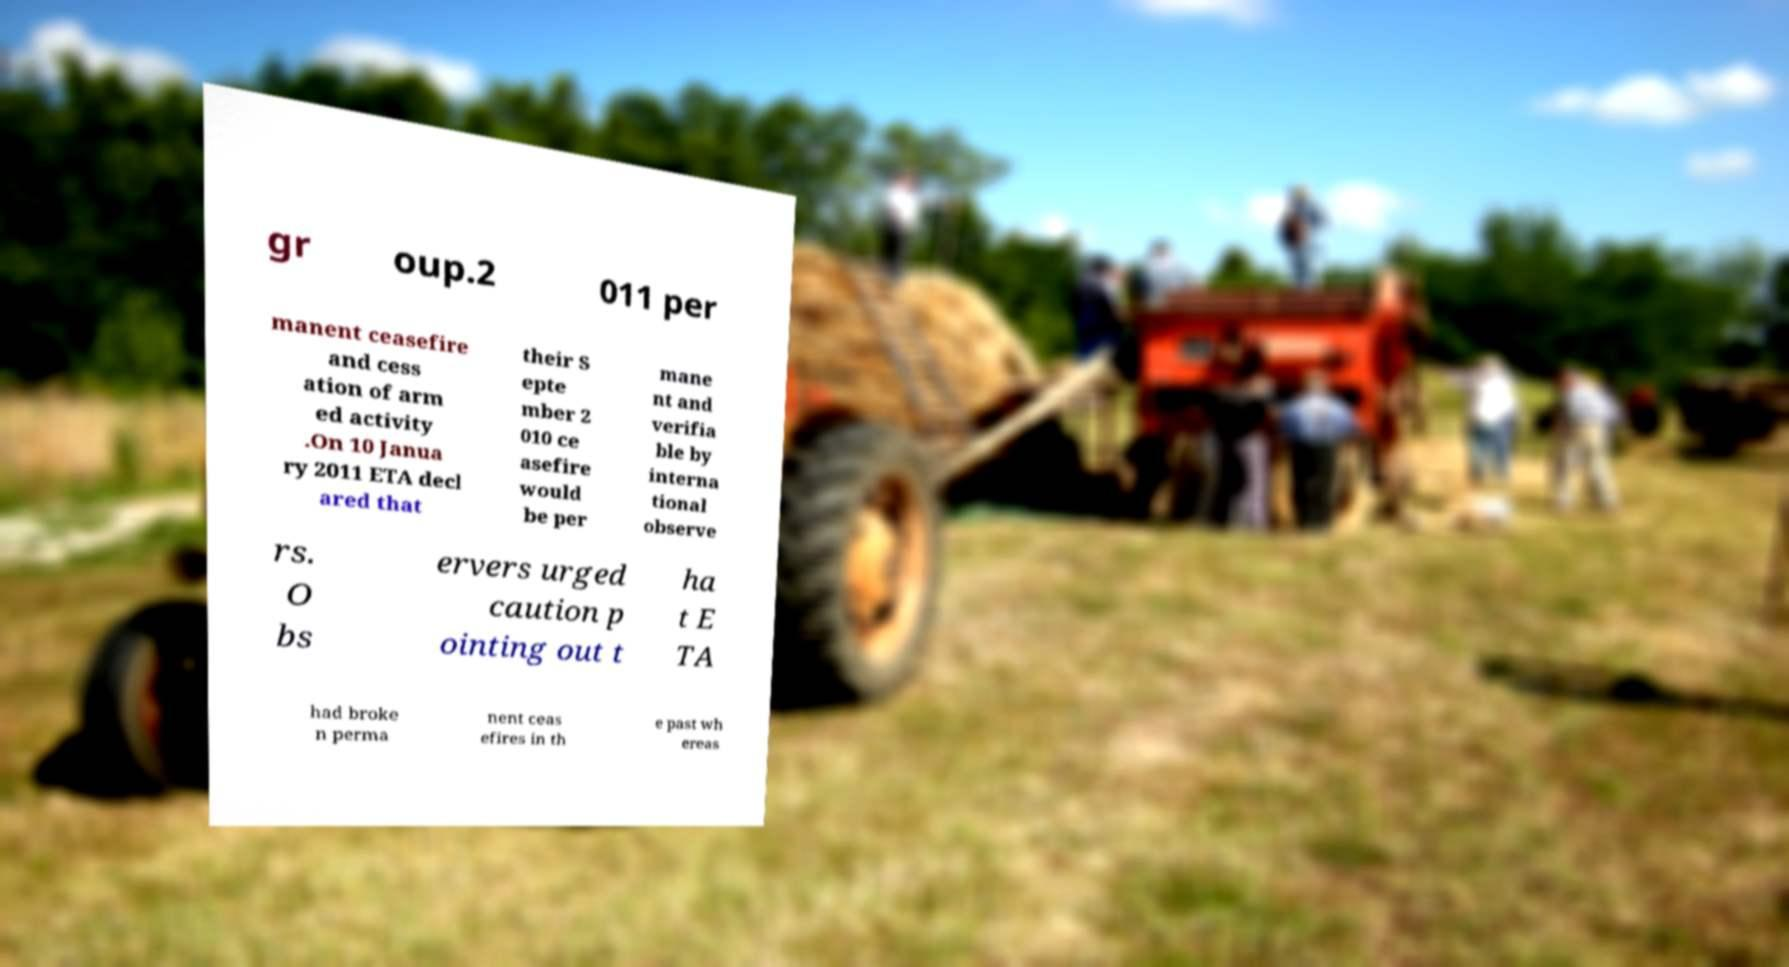For documentation purposes, I need the text within this image transcribed. Could you provide that? gr oup.2 011 per manent ceasefire and cess ation of arm ed activity .On 10 Janua ry 2011 ETA decl ared that their S epte mber 2 010 ce asefire would be per mane nt and verifia ble by interna tional observe rs. O bs ervers urged caution p ointing out t ha t E TA had broke n perma nent ceas efires in th e past wh ereas 